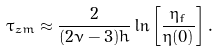Convert formula to latex. <formula><loc_0><loc_0><loc_500><loc_500>\tau _ { z m } \approx \frac { 2 } { ( 2 \nu - 3 ) h } \ln \left [ \frac { \eta _ { f } } { \eta ( 0 ) } \right ] .</formula> 